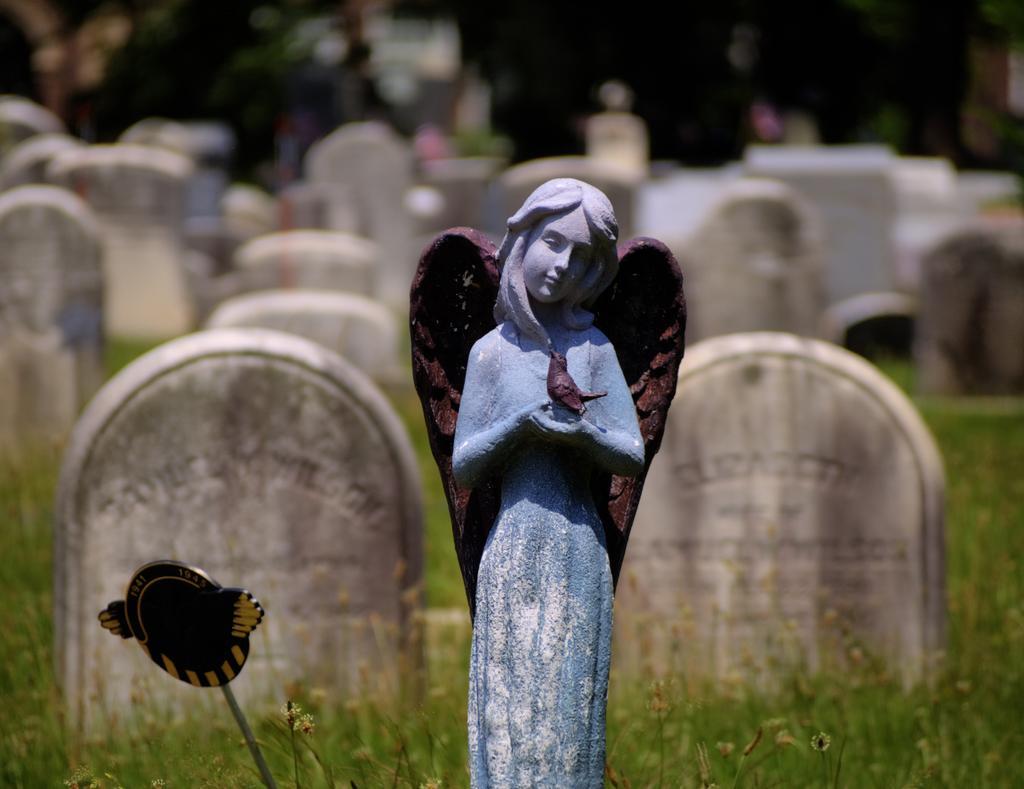How would you summarize this image in a sentence or two? In this image I can see a statue of a woman and grass. I can also see tombstones in the background. 